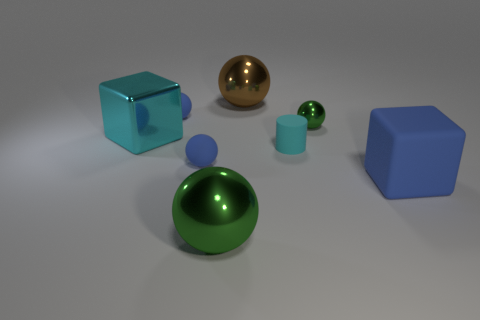Subtract 3 spheres. How many spheres are left? 2 Subtract all blue spheres. How many spheres are left? 3 Subtract all blocks. How many objects are left? 6 Add 5 small blue matte things. How many small blue matte things are left? 7 Add 8 blue rubber blocks. How many blue rubber blocks exist? 9 Add 1 big cyan shiny objects. How many objects exist? 9 Subtract all brown spheres. How many spheres are left? 4 Subtract 1 cyan cubes. How many objects are left? 7 Subtract all purple cylinders. Subtract all cyan cubes. How many cylinders are left? 1 Subtract all gray cylinders. How many green balls are left? 2 